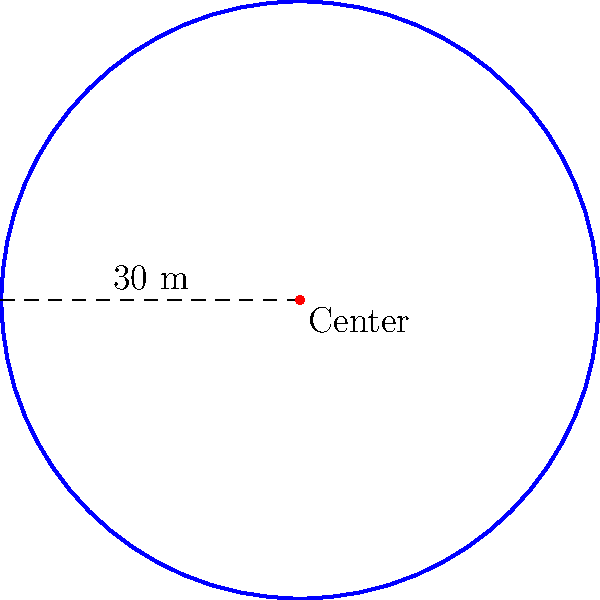During a Gaelic football training session, Coach Gavin Creedon sets up a circular training zone on the field. The radius of this zone is 30 meters. What is the perimeter of this circular training area? To find the perimeter of a circular area, we need to calculate its circumference. The formula for the circumference of a circle is:

$$ C = 2\pi r $$

Where:
- $C$ is the circumference (perimeter)
- $\pi$ is approximately 3.14159
- $r$ is the radius

Given:
- Radius $(r) = 30$ meters

Let's substitute these values into the formula:

$$ C = 2 \times \pi \times 30 $$
$$ C = 2 \times 3.14159 \times 30 $$
$$ C = 188.4954 \text{ meters} $$

Rounding to two decimal places:
$$ C \approx 188.50 \text{ meters} $$

Therefore, the perimeter of the circular training zone is approximately 188.50 meters.
Answer: 188.50 meters 